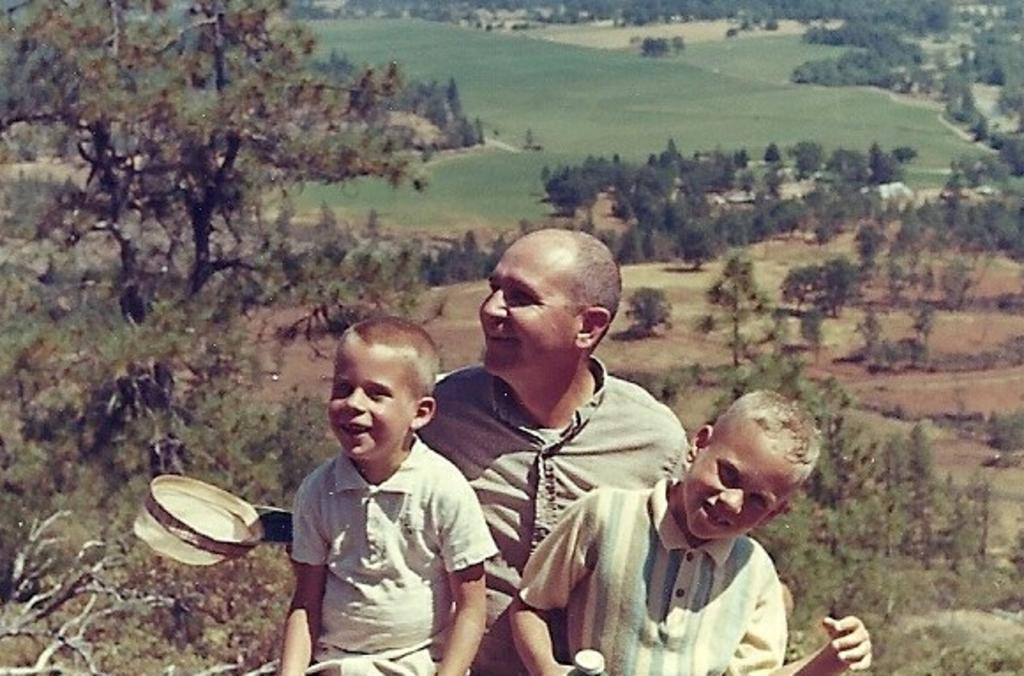What can be observed about the editing of the image? The image is edited. What is located in the middle of the image? There are trees and three persons in the middle of the image. Can you describe the people in the image? One of the persons is a man, and two of the persons are kids. What do the three persons have in common? All three persons are wearing shirts of the same color and are smiling. What type of humor can be seen in the image? There is no humor depicted in the image; it features three persons and trees. What is the distance between the trees and the people in the image? The provided facts do not give information about the distance between the trees and the people in the image. 